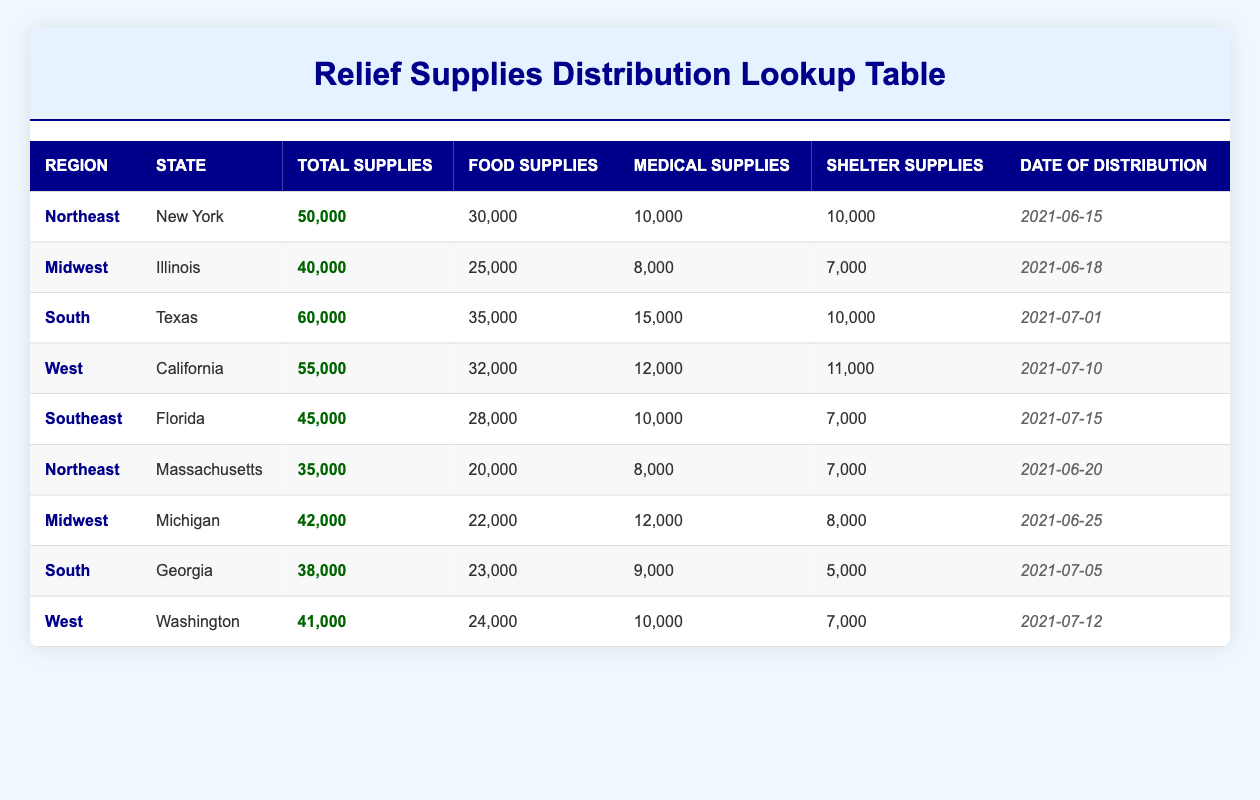What is the total amount of supplies distributed in Texas? The table shows that Texas has a total of 60,000 supplies distributed as indicated in the row for that state.
Answer: 60,000 Which state received the highest amount of medical supplies? By comparing the medical supplies column, Texas received 15,000, which is the highest value among all listed states.
Answer: Texas How many total supplies were distributed in the Northeast region? The Northeast region has two entries: New York (50,000) and Massachusetts (35,000). Summing these gives 50,000 + 35,000 = 85,000 supplies.
Answer: 85,000 Is the total amount of food supplies distributed in Georgia greater than that in Illinois? Georgia received 23,000 food supplies, while Illinois received 25,000. Since 23,000 is less than 25,000, the answer is no.
Answer: No What is the average number of shelter supplies distributed across all regions? The sum of shelter supplies is (10,000 + 7,000 + 10,000 + 11,000 + 7,000 + 7,000 + 8,000 + 5,000 + 7,000) = 72,000. Dividing by the number of entries (9) gives an average of 72,000 / 9 = 8,000.
Answer: 8,000 Which two states combined received more than 70,000 total supplies? Adding the total for Texas (60,000) and Georgia (38,000) gives 98,000, which is more than 70,000. Thus, Texas and Georgia together exceed this number.
Answer: Texas and Georgia How many food supplies were distributed in Florida? Florida has 28,000 food supplies as listed in the table.
Answer: 28,000 Is it true that California distributed more total supplies than Michigan? California distributed 55,000 supplies, while Michigan distributed 42,000 supplies. Since 55,000 is greater than 42,000, the statement is true.
Answer: Yes 